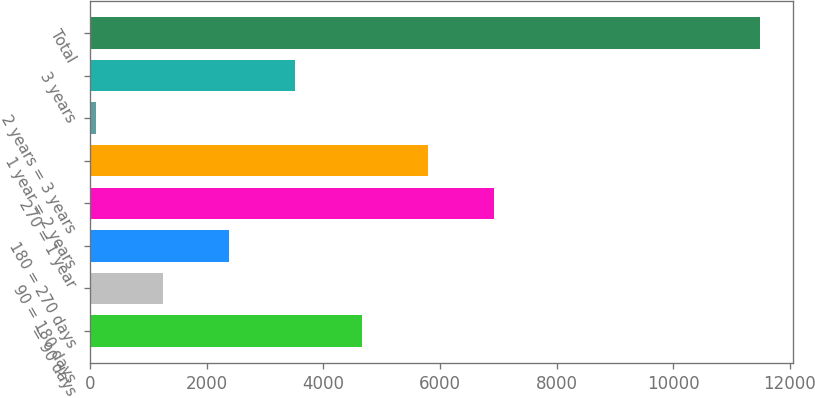<chart> <loc_0><loc_0><loc_500><loc_500><bar_chart><fcel>= 90 days<fcel>90 = 180 days<fcel>180 = 270 days<fcel>270 = 1 year<fcel>1 year = 2 years<fcel>2 years = 3 years<fcel>3 years<fcel>Total<nl><fcel>4660.08<fcel>1248.27<fcel>2385.54<fcel>6934.62<fcel>5797.35<fcel>111<fcel>3522.81<fcel>11483.7<nl></chart> 